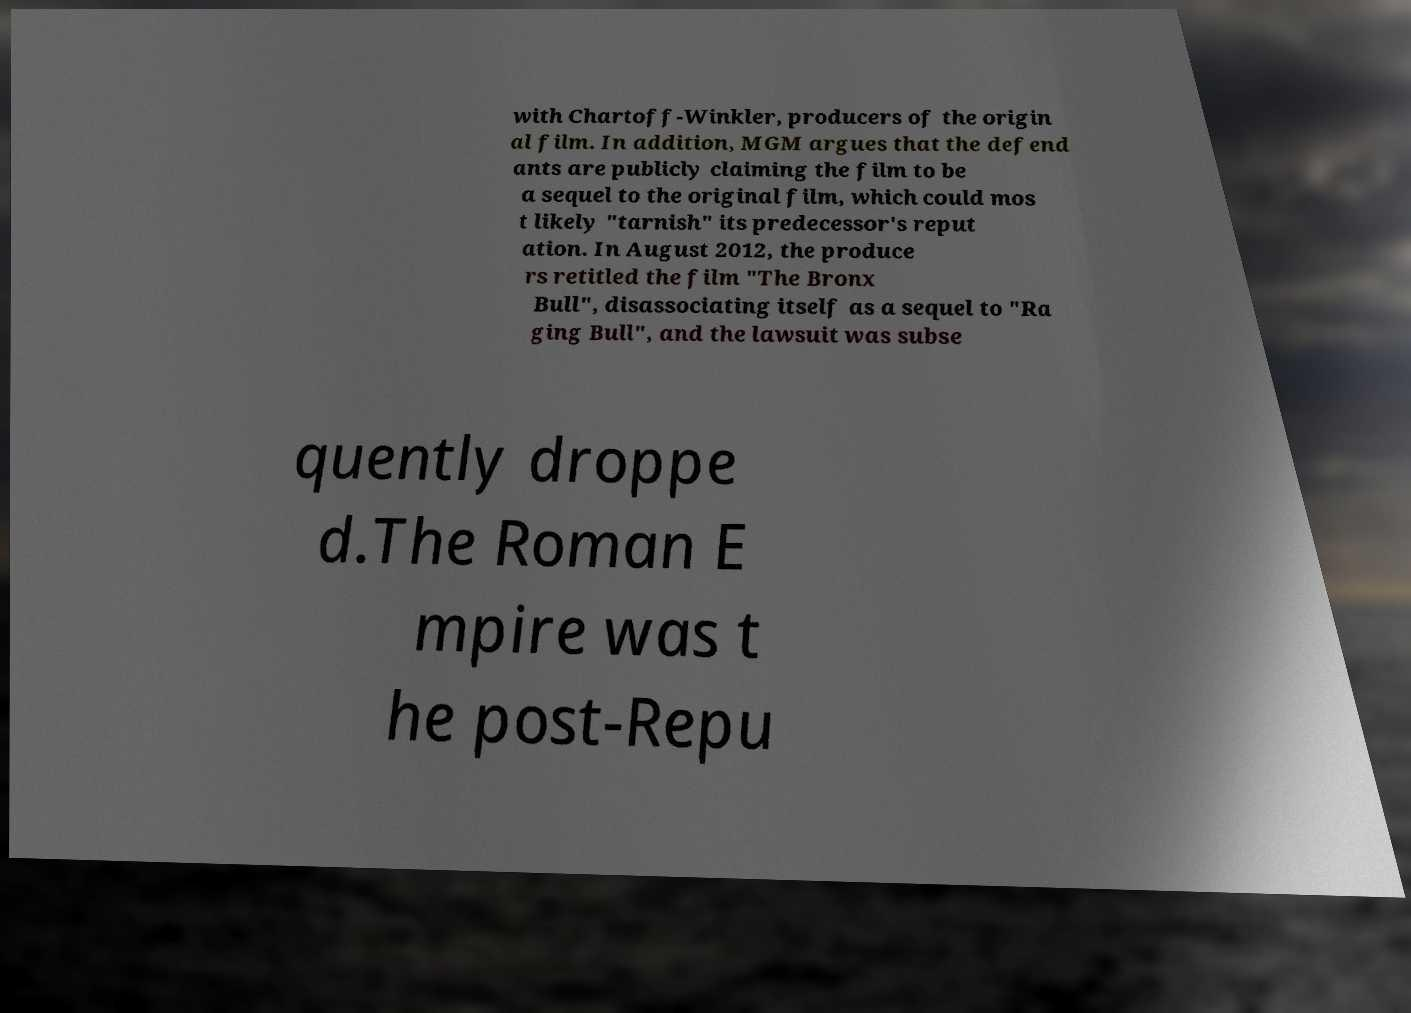Could you assist in decoding the text presented in this image and type it out clearly? with Chartoff-Winkler, producers of the origin al film. In addition, MGM argues that the defend ants are publicly claiming the film to be a sequel to the original film, which could mos t likely "tarnish" its predecessor's reput ation. In August 2012, the produce rs retitled the film "The Bronx Bull", disassociating itself as a sequel to "Ra ging Bull", and the lawsuit was subse quently droppe d.The Roman E mpire was t he post-Repu 